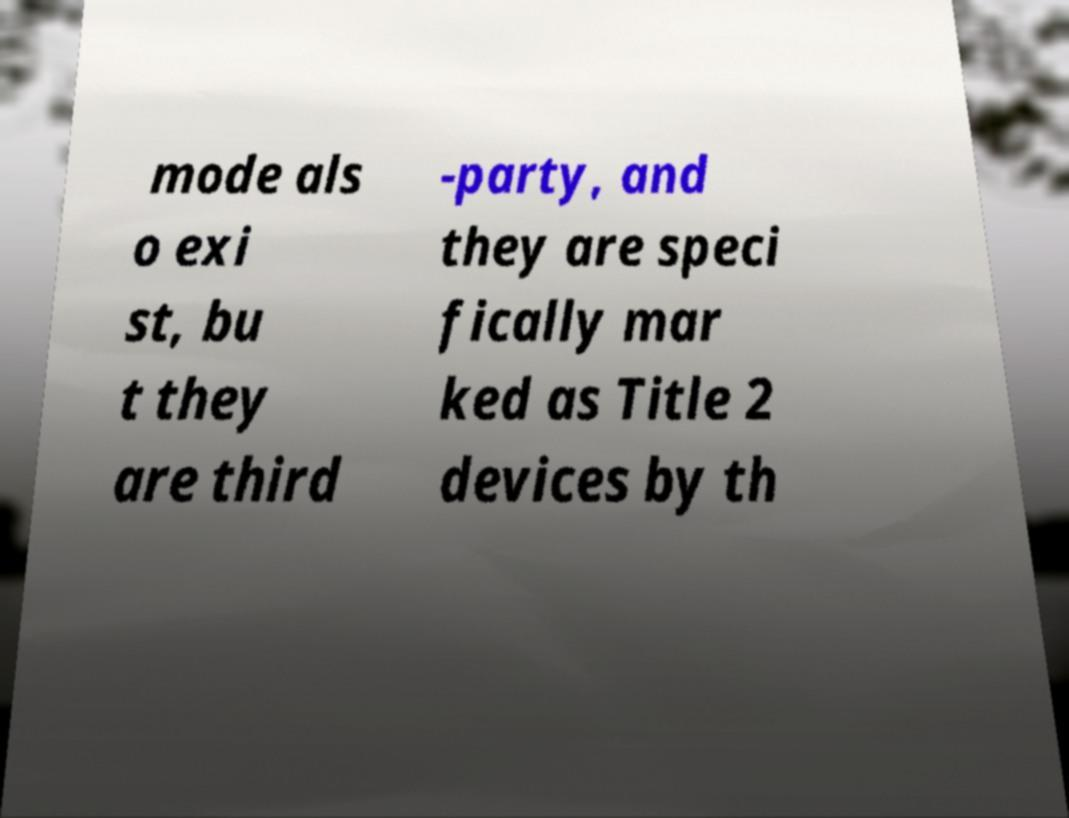What messages or text are displayed in this image? I need them in a readable, typed format. mode als o exi st, bu t they are third -party, and they are speci fically mar ked as Title 2 devices by th 